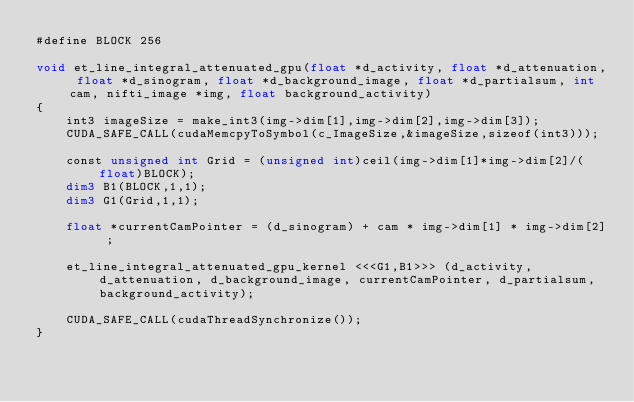<code> <loc_0><loc_0><loc_500><loc_500><_Cuda_>#define BLOCK 256

void et_line_integral_attenuated_gpu(float *d_activity, float *d_attenuation, float *d_sinogram, float *d_background_image, float *d_partialsum, int cam, nifti_image *img, float background_activity)
{
	int3 imageSize = make_int3(img->dim[1],img->dim[2],img->dim[3]);
	CUDA_SAFE_CALL(cudaMemcpyToSymbol(c_ImageSize,&imageSize,sizeof(int3)));
	
	const unsigned int Grid = (unsigned int)ceil(img->dim[1]*img->dim[2]/(float)BLOCK);
	dim3 B1(BLOCK,1,1);
	dim3 G1(Grid,1,1);
	
	float *currentCamPointer = (d_sinogram) + cam * img->dim[1] * img->dim[2] ;

	et_line_integral_attenuated_gpu_kernel <<<G1,B1>>> (d_activity, d_attenuation, d_background_image, currentCamPointer, d_partialsum, background_activity);

	CUDA_SAFE_CALL(cudaThreadSynchronize());
}


</code> 